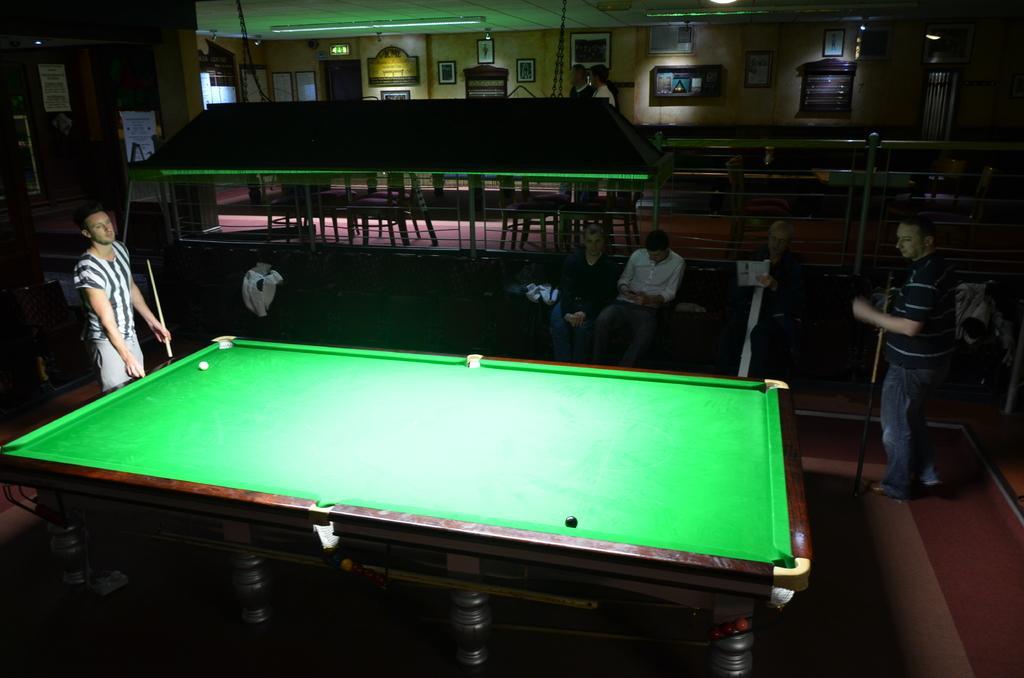In one or two sentences, can you explain what this image depicts? This is a place where the snooker table is arranged and there are some people sitting and two other people who are playing the game and also there are some frames, bulbs and some postures in the room. 